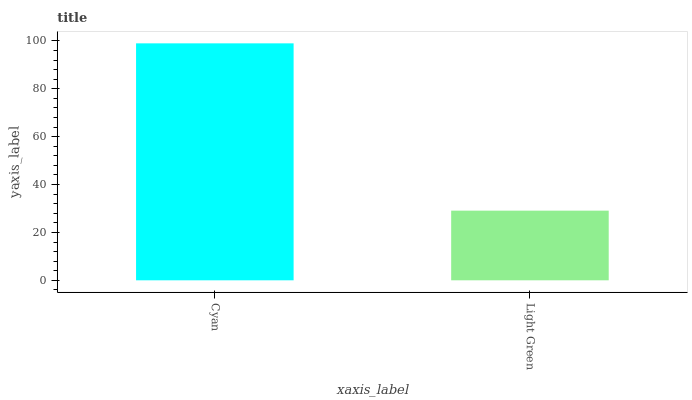Is Light Green the maximum?
Answer yes or no. No. Is Cyan greater than Light Green?
Answer yes or no. Yes. Is Light Green less than Cyan?
Answer yes or no. Yes. Is Light Green greater than Cyan?
Answer yes or no. No. Is Cyan less than Light Green?
Answer yes or no. No. Is Cyan the high median?
Answer yes or no. Yes. Is Light Green the low median?
Answer yes or no. Yes. Is Light Green the high median?
Answer yes or no. No. Is Cyan the low median?
Answer yes or no. No. 